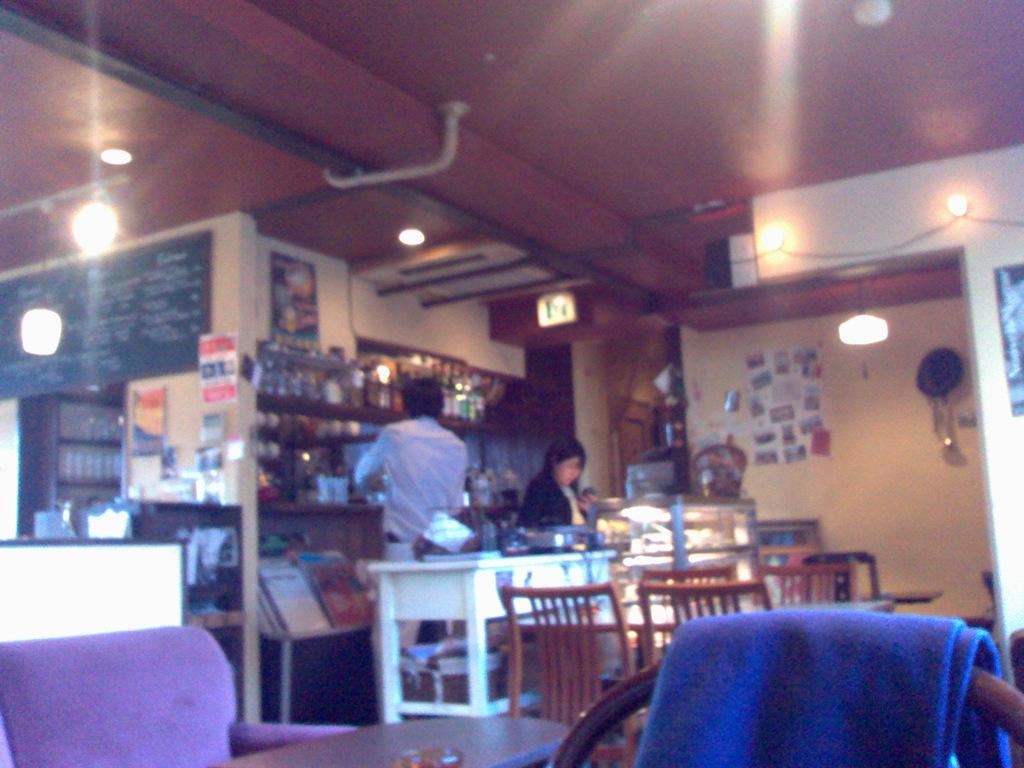What type of furniture is present in the image? There are chairs and tables in the image. How many people can be seen in the image? There are two persons standing in the image. What can be used for illumination in the image? There are lights visible in the image. What type of food is stored in containers in the image? There are food items in containers in the image. What type of list can be seen hanging on the wall in the image? There is no list visible on the wall in the image. 